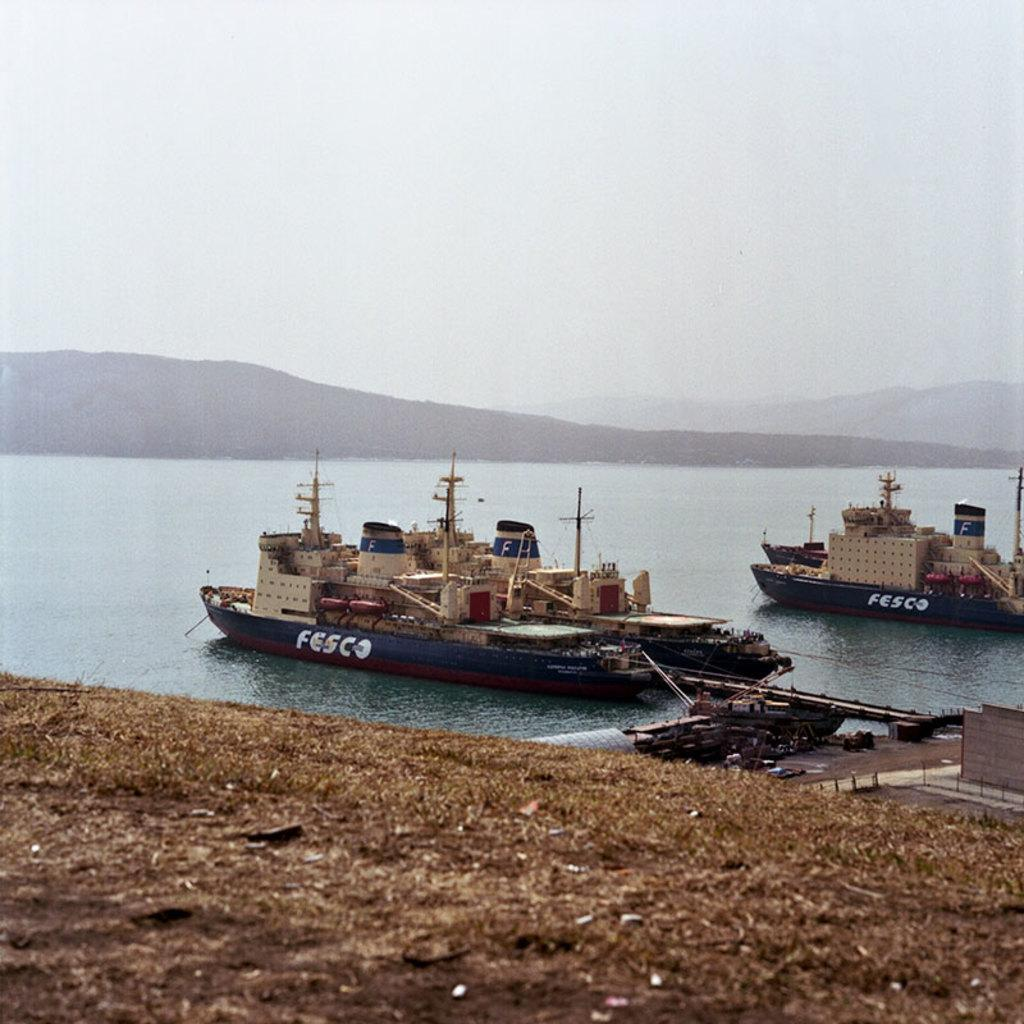<image>
Relay a brief, clear account of the picture shown. Two boats are docked by the beach and they both say Fesco in white letters on the side. 